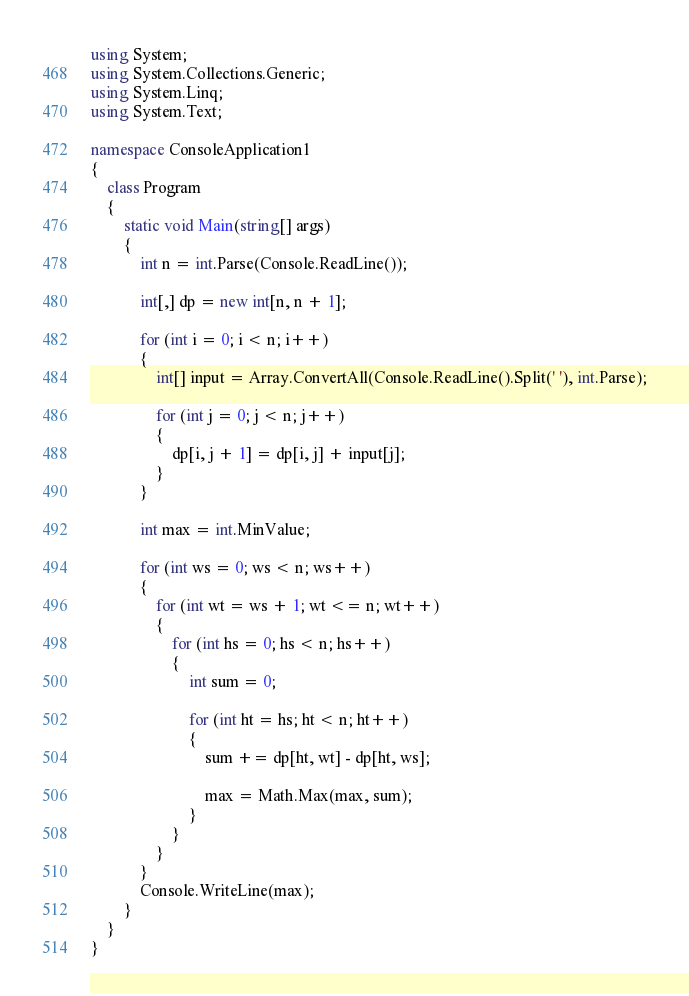Convert code to text. <code><loc_0><loc_0><loc_500><loc_500><_C#_>using System;
using System.Collections.Generic;
using System.Linq;
using System.Text;

namespace ConsoleApplication1
{
    class Program
    {
        static void Main(string[] args)
        {
            int n = int.Parse(Console.ReadLine());

            int[,] dp = new int[n, n + 1];

            for (int i = 0; i < n; i++)
            {
                int[] input = Array.ConvertAll(Console.ReadLine().Split(' '), int.Parse);

                for (int j = 0; j < n; j++)
                {
                    dp[i, j + 1] = dp[i, j] + input[j];
                }
            }

            int max = int.MinValue;

            for (int ws = 0; ws < n; ws++)
            {
                for (int wt = ws + 1; wt <= n; wt++)
                {
                    for (int hs = 0; hs < n; hs++)
                    {
                        int sum = 0;

                        for (int ht = hs; ht < n; ht++)
                        {
                            sum += dp[ht, wt] - dp[ht, ws];

                            max = Math.Max(max, sum);
                        }
                    }
                }
            }
            Console.WriteLine(max);
        }
    }
}</code> 